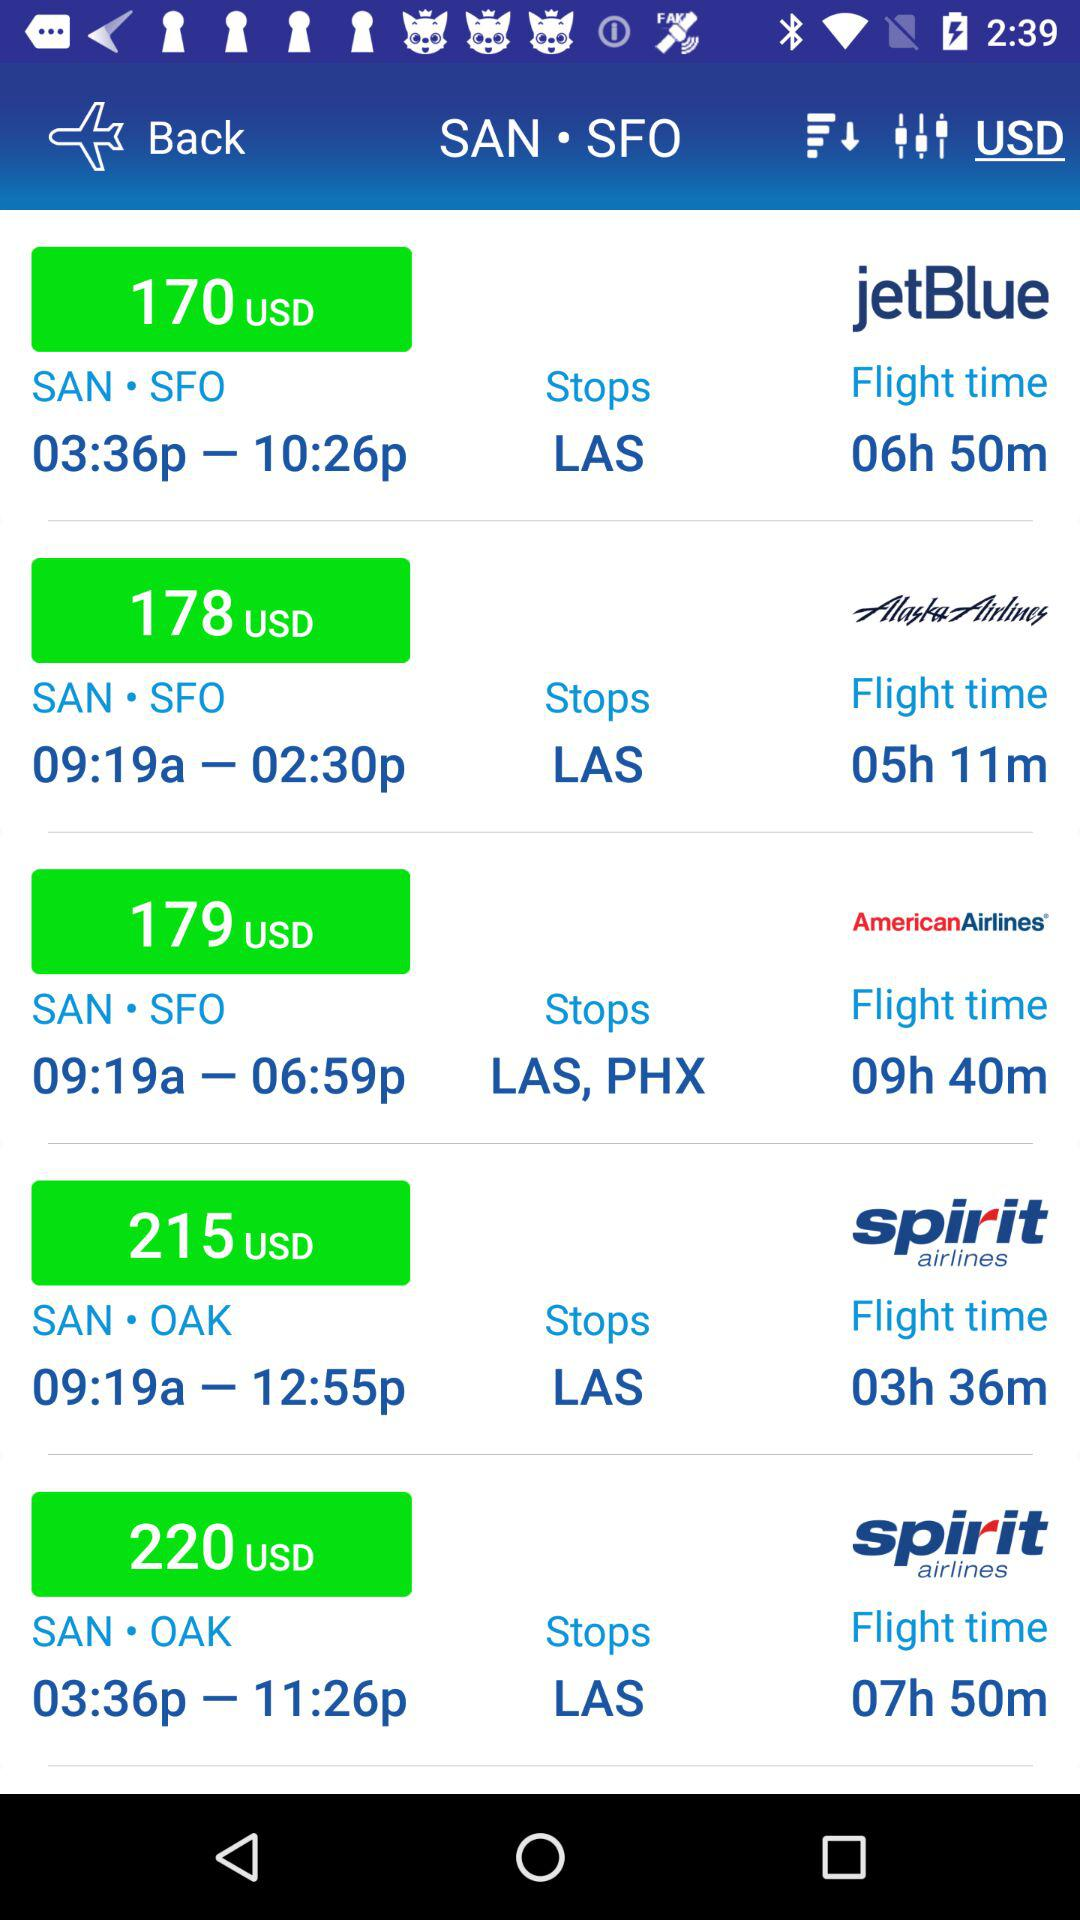What is the departure city? The departure city is SAN. 